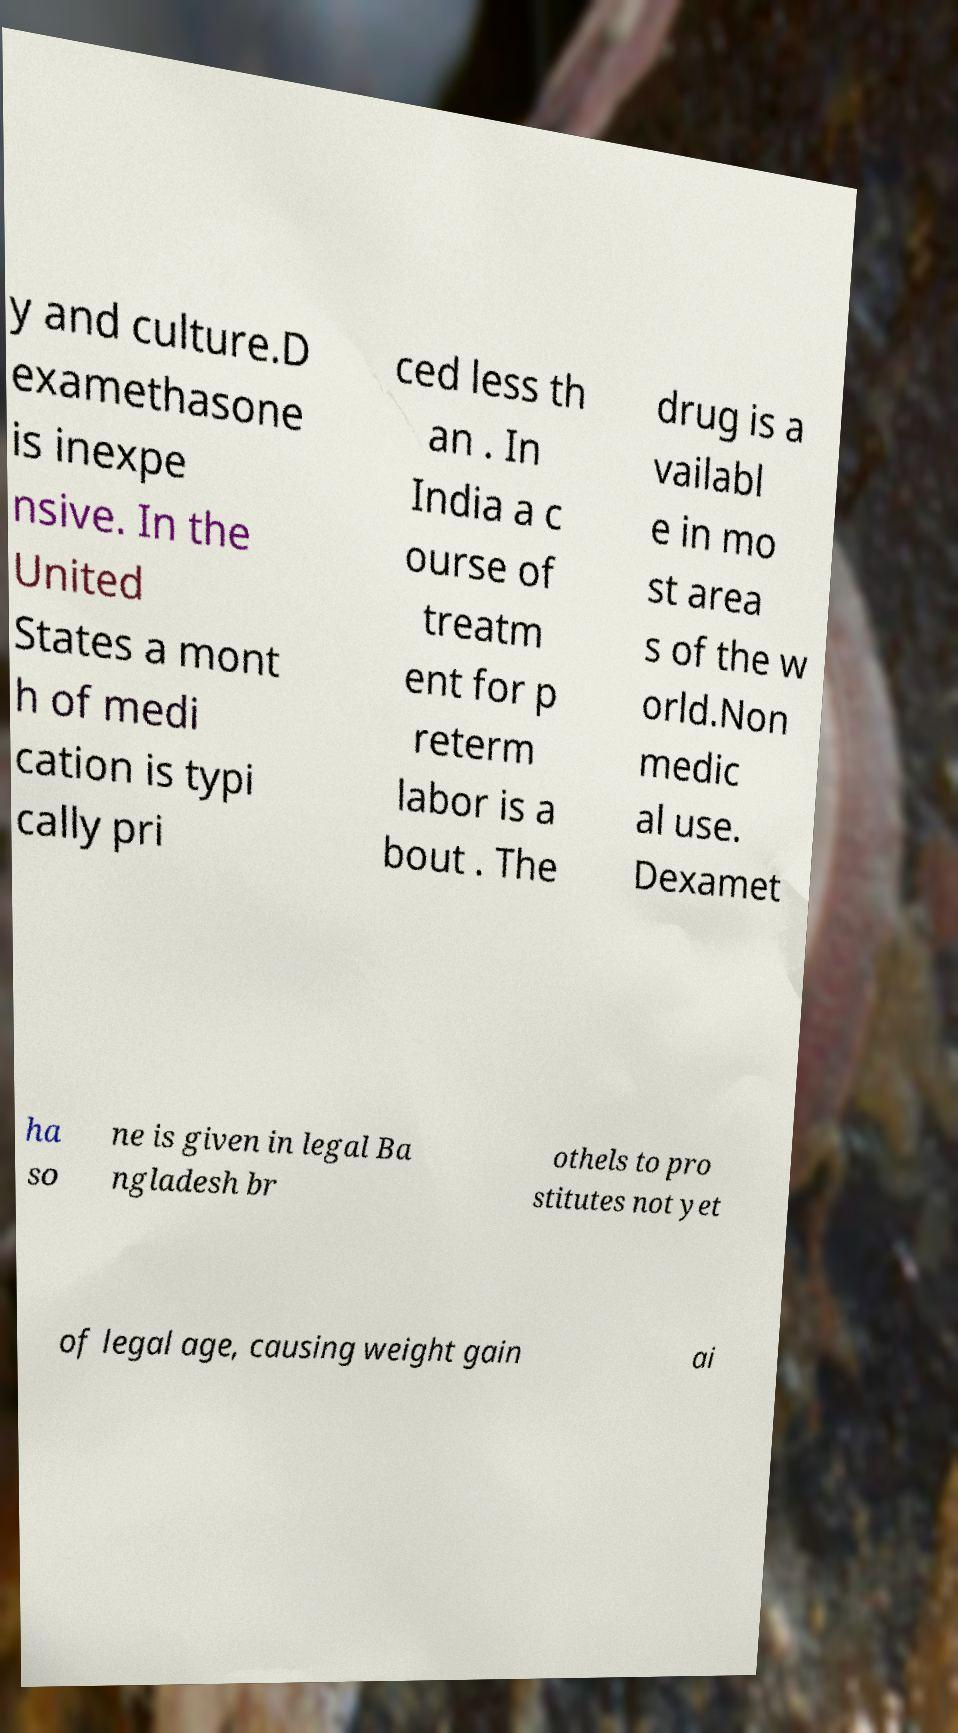Could you extract and type out the text from this image? y and culture.D examethasone is inexpe nsive. In the United States a mont h of medi cation is typi cally pri ced less th an . In India a c ourse of treatm ent for p reterm labor is a bout . The drug is a vailabl e in mo st area s of the w orld.Non medic al use. Dexamet ha so ne is given in legal Ba ngladesh br othels to pro stitutes not yet of legal age, causing weight gain ai 